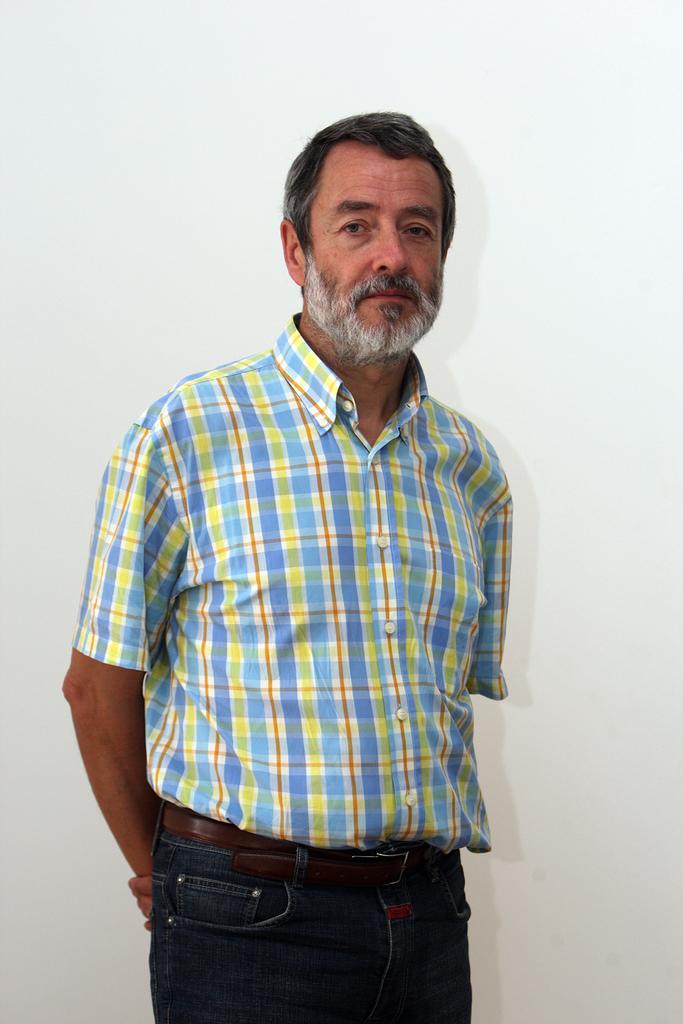In one or two sentences, can you explain what this image depicts? In this picture I can see a man standing and I can see white color background. 